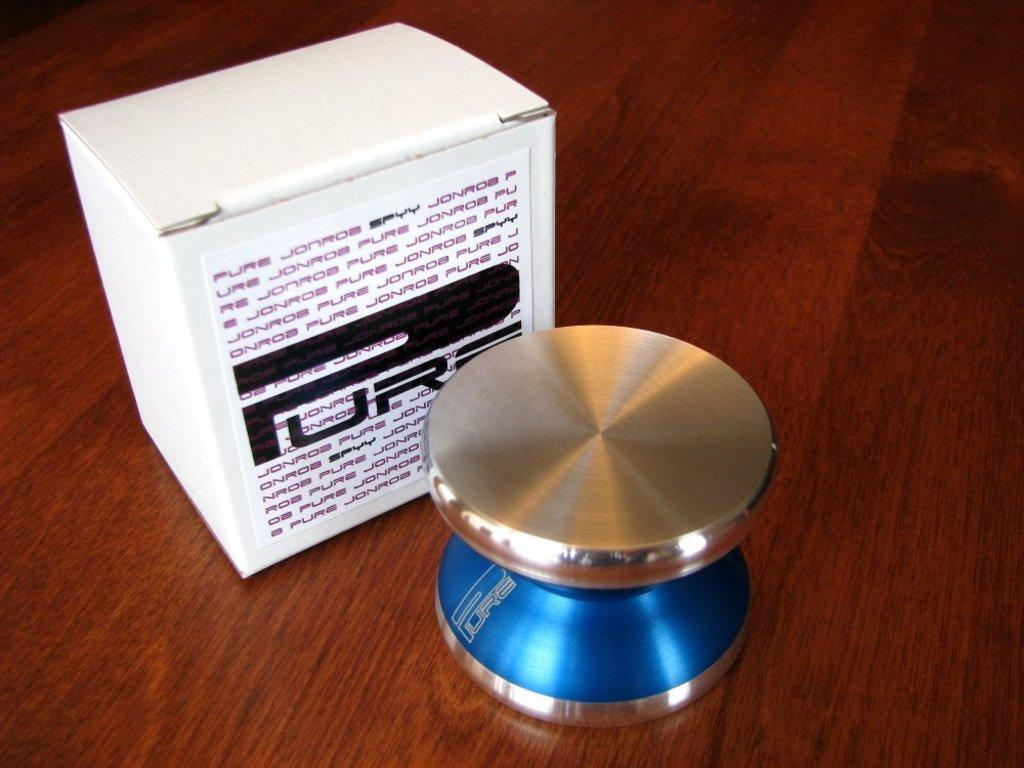<image>
Offer a succinct explanation of the picture presented. A blue container with a white box behind it with the word pure. 